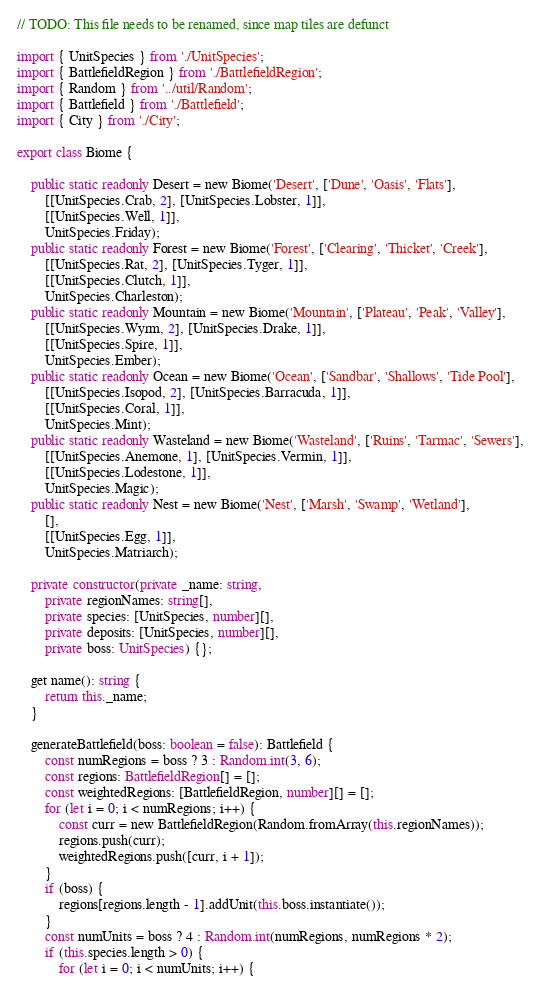Convert code to text. <code><loc_0><loc_0><loc_500><loc_500><_TypeScript_>// TODO: This file needs to be renamed, since map tiles are defunct

import { UnitSpecies } from './UnitSpecies';
import { BattlefieldRegion } from './BattlefieldRegion';
import { Random } from '../util/Random';
import { Battlefield } from './Battlefield';
import { City } from './City';

export class Biome {

    public static readonly Desert = new Biome('Desert', ['Dune', 'Oasis', 'Flats'],
        [[UnitSpecies.Crab, 2], [UnitSpecies.Lobster, 1]],
        [[UnitSpecies.Well, 1]],
        UnitSpecies.Friday);
    public static readonly Forest = new Biome('Forest', ['Clearing', 'Thicket', 'Creek'],
        [[UnitSpecies.Rat, 2], [UnitSpecies.Tyger, 1]],
        [[UnitSpecies.Clutch, 1]],
        UnitSpecies.Charleston);
    public static readonly Mountain = new Biome('Mountain', ['Plateau', 'Peak', 'Valley'],
        [[UnitSpecies.Wyrm, 2], [UnitSpecies.Drake, 1]],
        [[UnitSpecies.Spire, 1]],
        UnitSpecies.Ember);
    public static readonly Ocean = new Biome('Ocean', ['Sandbar', 'Shallows', 'Tide Pool'],
        [[UnitSpecies.Isopod, 2], [UnitSpecies.Barracuda, 1]],
        [[UnitSpecies.Coral, 1]],
        UnitSpecies.Mint);
    public static readonly Wasteland = new Biome('Wasteland', ['Ruins', 'Tarmac', 'Sewers'],
        [[UnitSpecies.Anemone, 1], [UnitSpecies.Vermin, 1]],
        [[UnitSpecies.Lodestone, 1]],
        UnitSpecies.Magic);
    public static readonly Nest = new Biome('Nest', ['Marsh', 'Swamp', 'Wetland'],
        [],
        [[UnitSpecies.Egg, 1]],
        UnitSpecies.Matriarch);

    private constructor(private _name: string,
        private regionNames: string[],
        private species: [UnitSpecies, number][],
        private deposits: [UnitSpecies, number][],
        private boss: UnitSpecies) {};

    get name(): string {
        return this._name;
    }

    generateBattlefield(boss: boolean = false): Battlefield {
        const numRegions = boss ? 3 : Random.int(3, 6);
        const regions: BattlefieldRegion[] = [];
        const weightedRegions: [BattlefieldRegion, number][] = [];
        for (let i = 0; i < numRegions; i++) {
            const curr = new BattlefieldRegion(Random.fromArray(this.regionNames));
            regions.push(curr);
            weightedRegions.push([curr, i + 1]);
        }
        if (boss) {
            regions[regions.length - 1].addUnit(this.boss.instantiate());
        }
        const numUnits = boss ? 4 : Random.int(numRegions, numRegions * 2);
        if (this.species.length > 0) {
            for (let i = 0; i < numUnits; i++) {</code> 